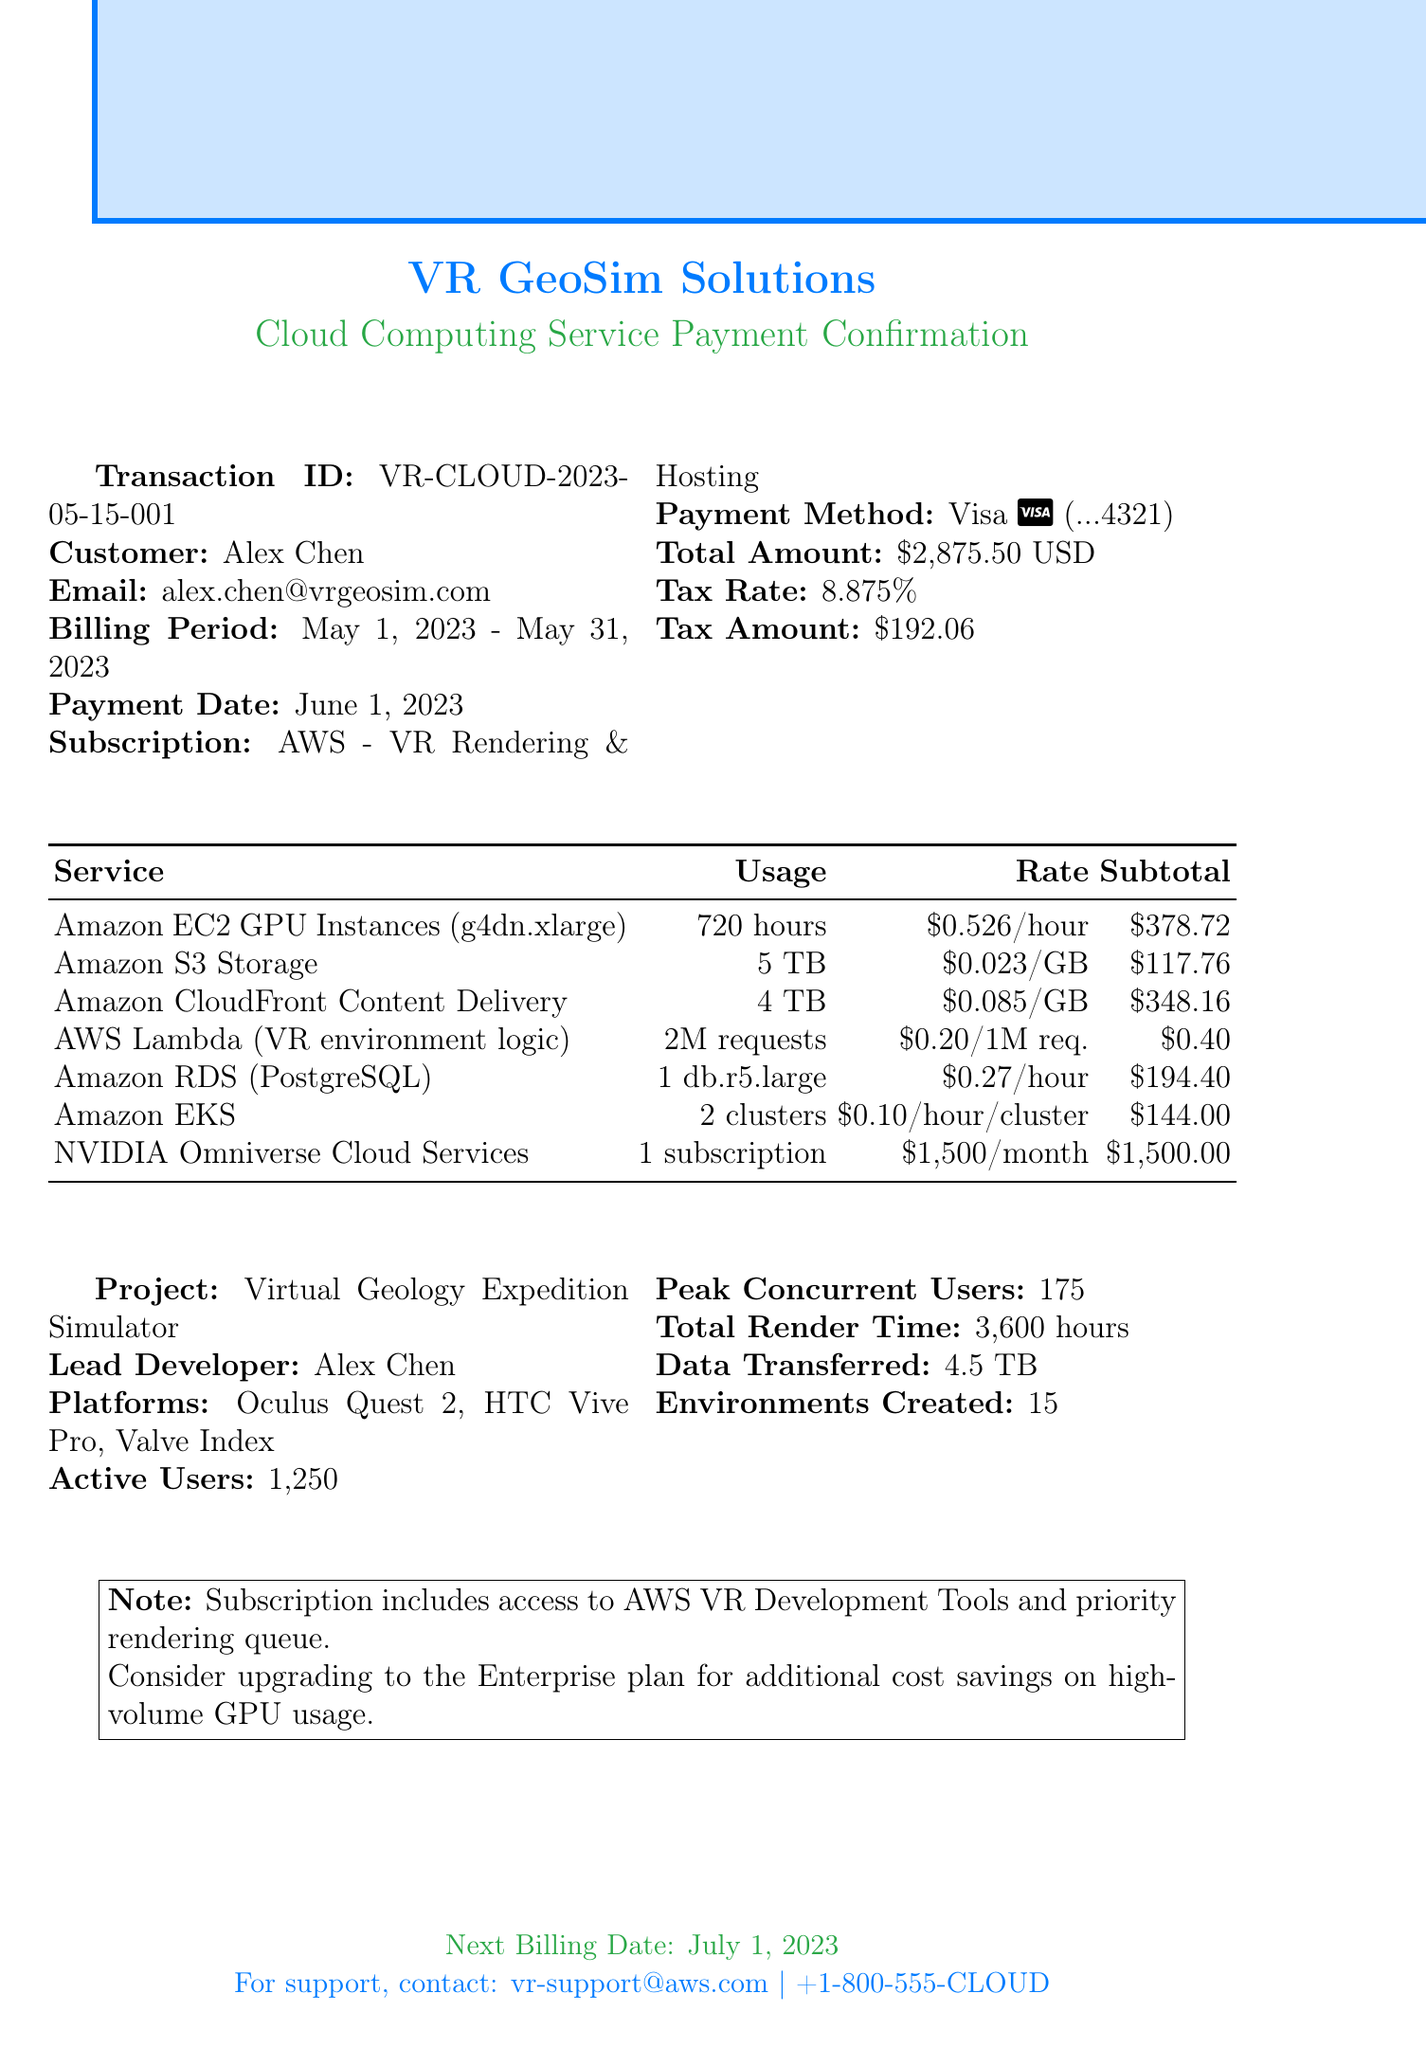What is the transaction ID? The transaction ID is specified in the document to identify the payment transaction.
Answer: VR-CLOUD-2023-05-15-001 Who is the customer? The customer's name is provided in the document to indicate who made the payment.
Answer: Alex Chen What is the total amount? The total amount summarizes all charges and taxes related to the subscription for the billing period.
Answer: $2,875.50 What is the billing period? The billing period specifies the time frame for which the services were billed.
Answer: May 1, 2023 - May 31, 2023 How many active users are there? The document states the number of active users utilizing the VR service during the billing period.
Answer: 1250 What service account for the highest charge? The itemized charges show individual service costs where one specific item might have the highest cost.
Answer: NVIDIA Omniverse Cloud Services What is the tax rate? The document presents the percentage to calculate the tax on the total amount.
Answer: 8.875% What is the project name? The project name indicates the specific application for which the cloud services are being used.
Answer: Virtual Geology Expedition Simulator When is the next billing date? The document provides the date when the next billing period starts following the current one.
Answer: July 1, 2023 What is included in the subscription? Additional notes inform about the perks and features included within the subscription plan.
Answer: Access to AWS VR Development Tools and priority rendering queue 